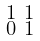<formula> <loc_0><loc_0><loc_500><loc_500>\begin{smallmatrix} 1 & 1 \\ 0 & 1 \end{smallmatrix}</formula> 